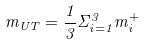Convert formula to latex. <formula><loc_0><loc_0><loc_500><loc_500>m _ { U T } = \frac { 1 } { 3 } \Sigma _ { i = 1 } ^ { 3 } m _ { i } ^ { + }</formula> 